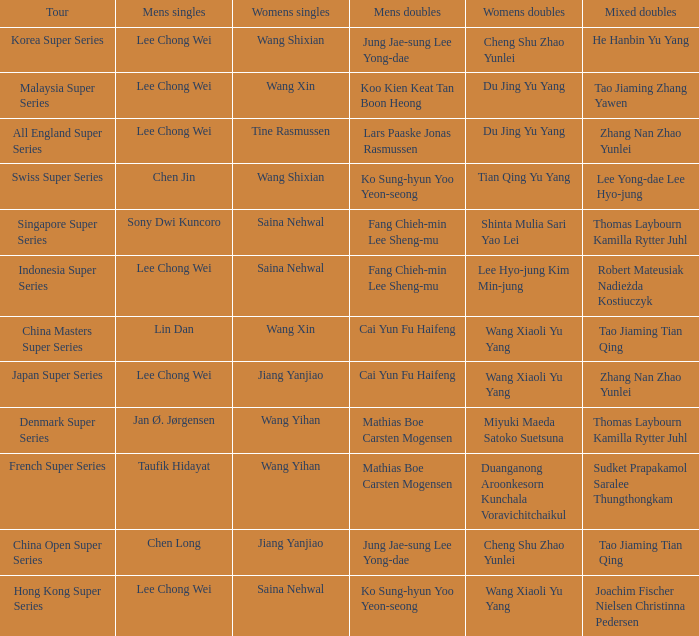Who is the women's doubles when the mixed doubles are sudket prapakamol saralee thungthongkam? Duanganong Aroonkesorn Kunchala Voravichitchaikul. 